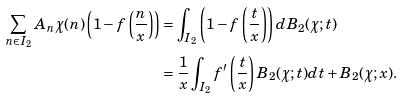<formula> <loc_0><loc_0><loc_500><loc_500>\sum _ { n \in I _ { 2 } } A _ { n } \chi ( n ) \left ( 1 - f \left ( \frac { n } { x } \right ) \right ) & = \int _ { I _ { 2 } } \left ( 1 - f \left ( \frac { t } { x } \right ) \right ) d B _ { 2 } ( \chi ; t ) \\ & = \frac { 1 } { x } \int _ { I _ { 2 } } f ^ { \prime } \left ( \frac { t } { x } \right ) B _ { 2 } ( \chi ; t ) d t + B _ { 2 } ( \chi ; x ) .</formula> 